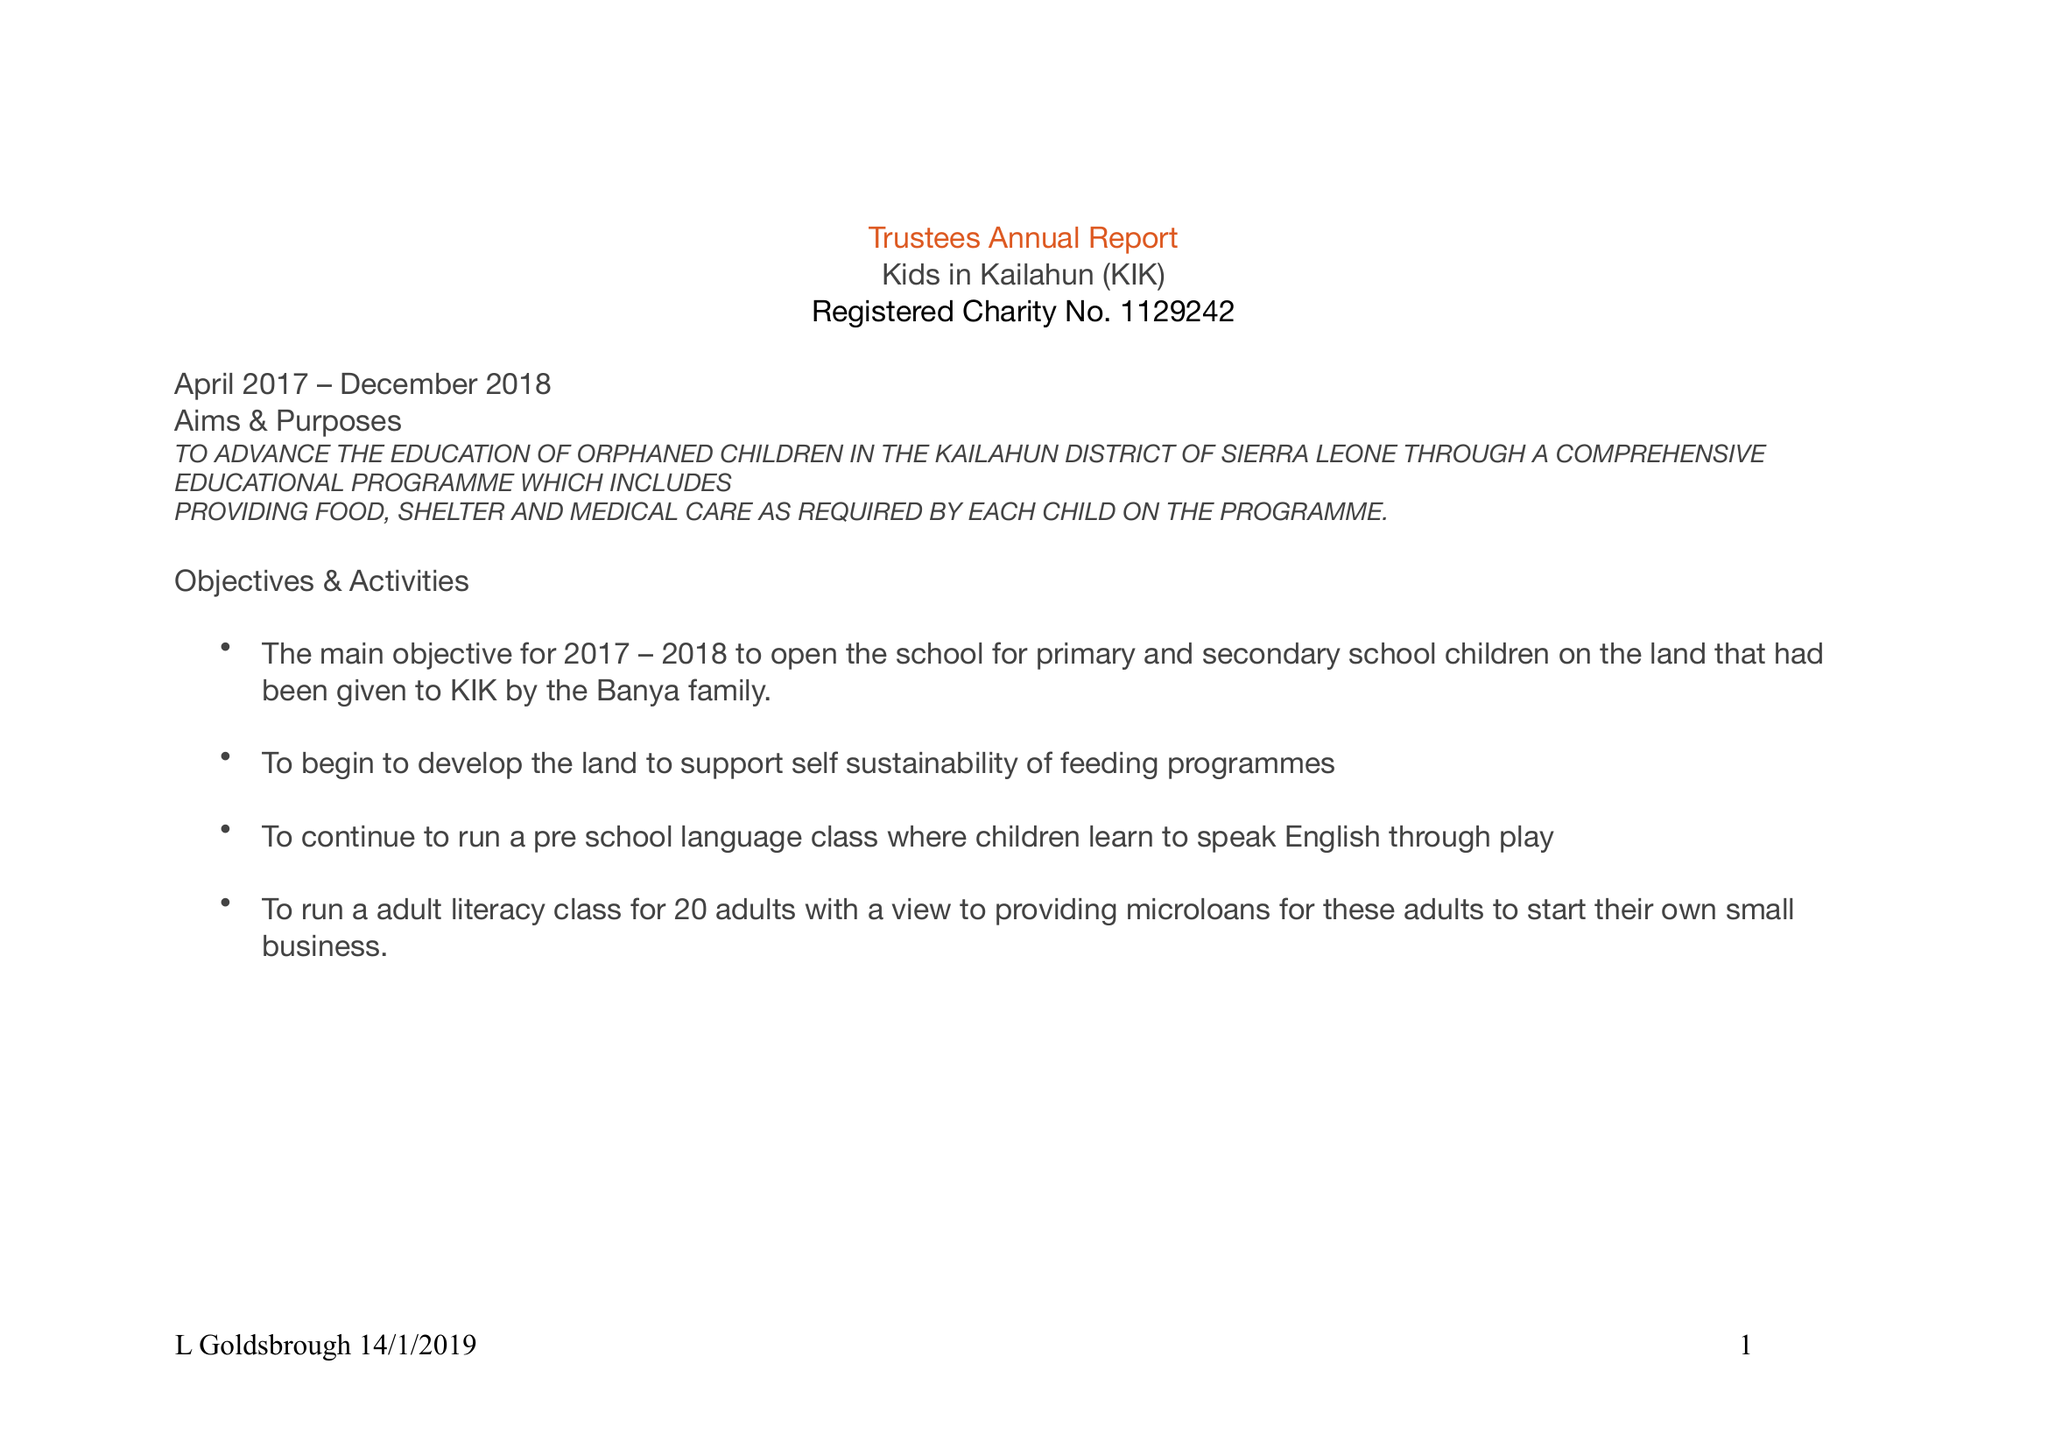What is the value for the report_date?
Answer the question using a single word or phrase. 2018-03-31 